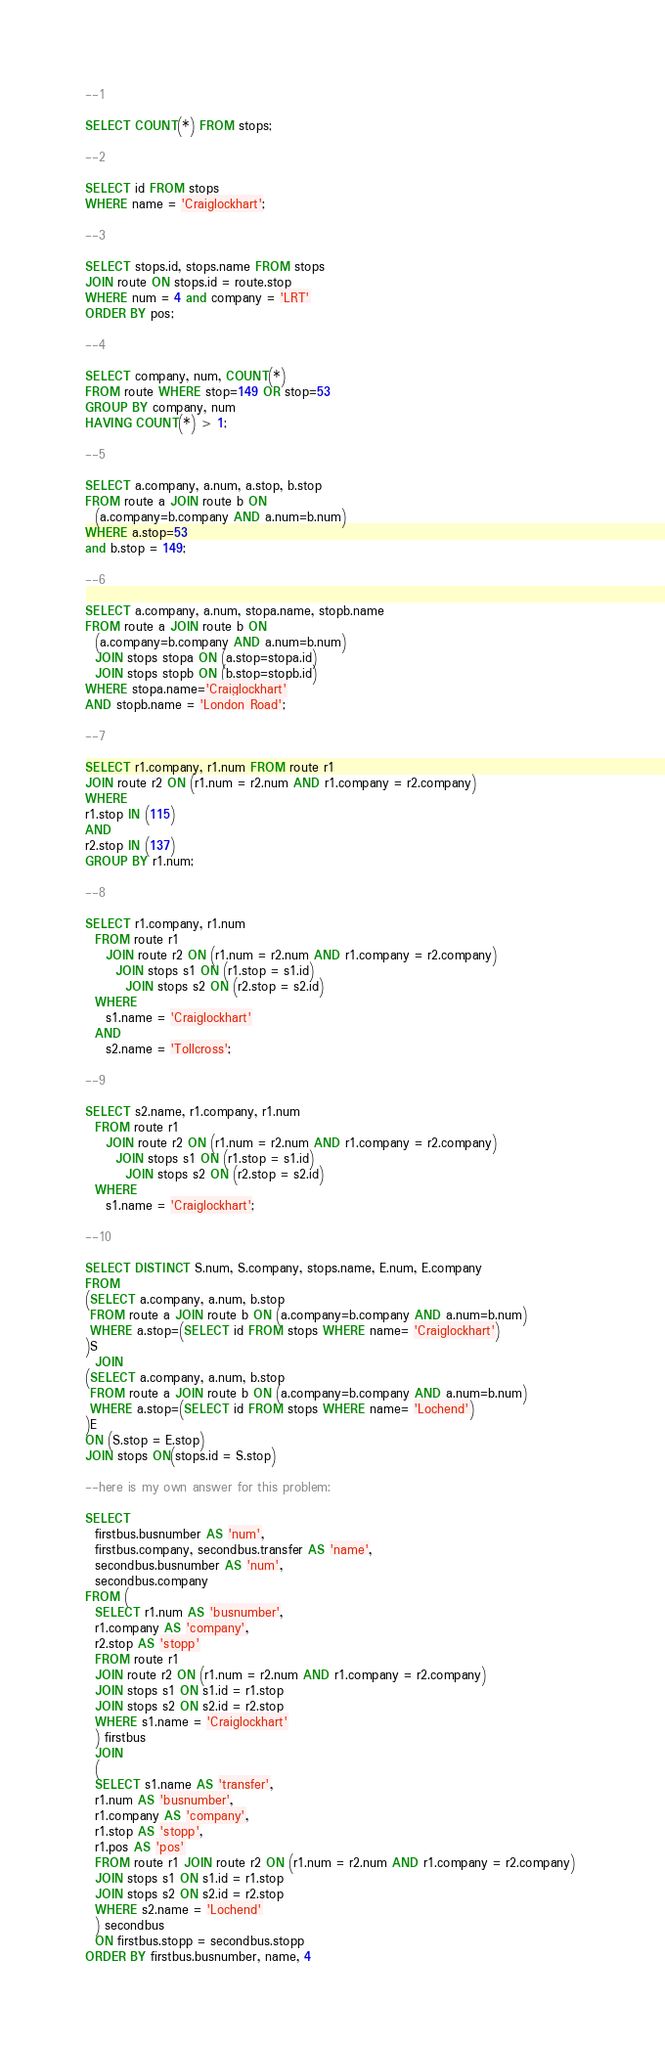<code> <loc_0><loc_0><loc_500><loc_500><_SQL_>--1

SELECT COUNT(*) FROM stops;

--2

SELECT id FROM stops
WHERE name = 'Craiglockhart';

--3

SELECT stops.id, stops.name FROM stops 
JOIN route ON stops.id = route.stop
WHERE num = 4 and company = 'LRT'
ORDER BY pos;

--4

SELECT company, num, COUNT(*)
FROM route WHERE stop=149 OR stop=53
GROUP BY company, num
HAVING COUNT(*) > 1;

--5

SELECT a.company, a.num, a.stop, b.stop
FROM route a JOIN route b ON
  (a.company=b.company AND a.num=b.num)
WHERE a.stop=53
and b.stop = 149;

--6

SELECT a.company, a.num, stopa.name, stopb.name
FROM route a JOIN route b ON
  (a.company=b.company AND a.num=b.num)
  JOIN stops stopa ON (a.stop=stopa.id)
  JOIN stops stopb ON (b.stop=stopb.id)
WHERE stopa.name='Craiglockhart'
AND stopb.name = 'London Road';

--7

SELECT r1.company, r1.num FROM route r1
JOIN route r2 ON (r1.num = r2.num AND r1.company = r2.company)
WHERE 
r1.stop IN (115)
AND
r2.stop IN (137)
GROUP BY r1.num;

--8

SELECT r1.company, r1.num
  FROM route r1 
    JOIN route r2 ON (r1.num = r2.num AND r1.company = r2.company) 
      JOIN stops s1 ON (r1.stop = s1.id) 
        JOIN stops s2 ON (r2.stop = s2.id) 
  WHERE 
    s1.name = 'Craiglockhart' 
  AND 
    s2.name = 'Tollcross';

--9

SELECT s2.name, r1.company, r1.num
  FROM route r1 
    JOIN route r2 ON (r1.num = r2.num AND r1.company = r2.company) 
      JOIN stops s1 ON (r1.stop = s1.id) 
        JOIN stops s2 ON (r2.stop = s2.id) 
  WHERE 
    s1.name = 'Craiglockhart';

--10

SELECT DISTINCT S.num, S.company, stops.name, E.num, E.company
FROM
(SELECT a.company, a.num, b.stop
 FROM route a JOIN route b ON (a.company=b.company AND a.num=b.num)
 WHERE a.stop=(SELECT id FROM stops WHERE name= 'Craiglockhart')
)S
  JOIN
(SELECT a.company, a.num, b.stop
 FROM route a JOIN route b ON (a.company=b.company AND a.num=b.num)
 WHERE a.stop=(SELECT id FROM stops WHERE name= 'Lochend')
)E
ON (S.stop = E.stop)
JOIN stops ON(stops.id = S.stop)

--here is my own answer for this problem:

SELECT 
  firstbus.busnumber AS 'num', 
  firstbus.company, secondbus.transfer AS 'name', 
  secondbus.busnumber AS 'num', 
  secondbus.company 
FROM (
  SELECT r1.num AS 'busnumber', 
  r1.company AS 'company', 
  r2.stop AS 'stopp' 
  FROM route r1 
  JOIN route r2 ON (r1.num = r2.num AND r1.company = r2.company) 
  JOIN stops s1 ON s1.id = r1.stop
  JOIN stops s2 ON s2.id = r2.stop
  WHERE s1.name = 'Craiglockhart'
  ) firstbus
  JOIN
  (
  SELECT s1.name AS 'transfer', 
  r1.num AS 'busnumber', 
  r1.company AS 'company', 
  r1.stop AS 'stopp', 
  r1.pos AS 'pos' 
  FROM route r1 JOIN route r2 ON (r1.num = r2.num AND r1.company = r2.company) 
  JOIN stops s1 ON s1.id = r1.stop
  JOIN stops s2 ON s2.id = r2.stop
  WHERE s2.name = 'Lochend'
  ) secondbus
  ON firstbus.stopp = secondbus.stopp
ORDER BY firstbus.busnumber, name, 4
</code> 